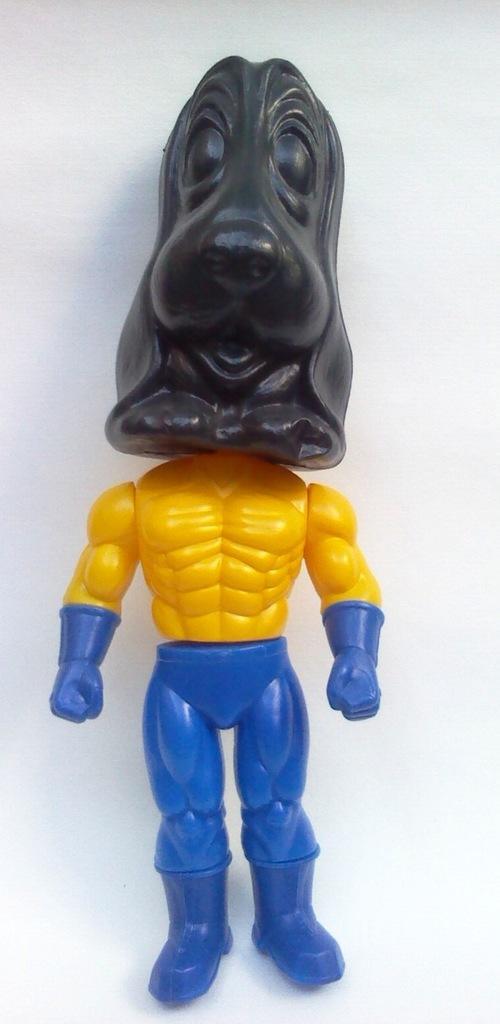Could you give a brief overview of what you see in this image? In this image we can see a toy robot. 